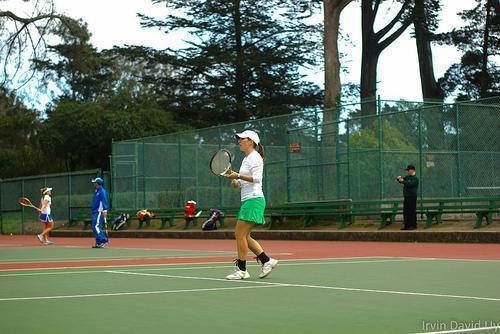How many women playing in the court?
Give a very brief answer. 2. How many people are wearing blue cloth?
Give a very brief answer. 1. 